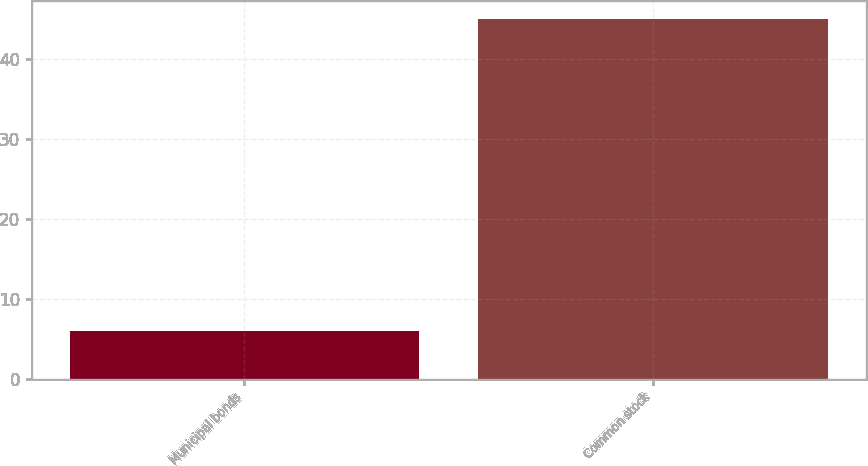Convert chart to OTSL. <chart><loc_0><loc_0><loc_500><loc_500><bar_chart><fcel>Municipal bonds<fcel>Common stock<nl><fcel>6<fcel>45<nl></chart> 